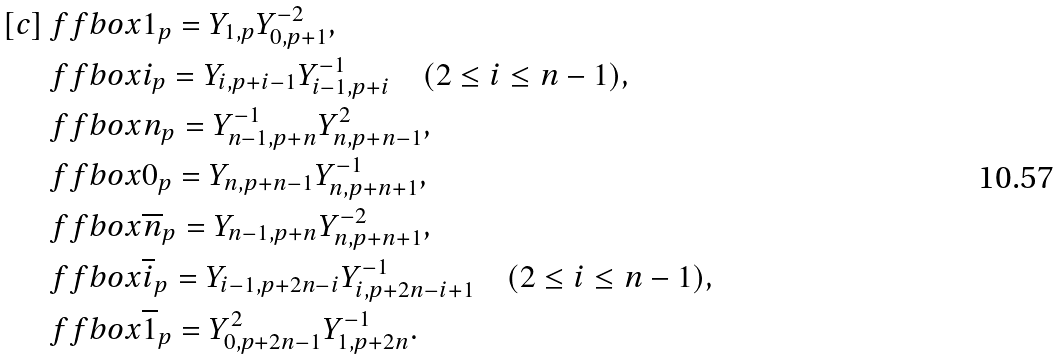Convert formula to latex. <formula><loc_0><loc_0><loc_500><loc_500>[ c ] & \ f f b o x { 1 } _ { p } = Y _ { 1 , p } Y _ { 0 , p + 1 } ^ { - 2 } , \\ & \ f f b o x { i } _ { p } = Y _ { i , p + i - 1 } Y _ { i - 1 , p + i } ^ { - 1 } \quad ( 2 \leq i \leq n - 1 ) , \\ & \ f f b o x { n } _ { p } = Y _ { n - 1 , p + n } ^ { - 1 } Y _ { n , p + n - 1 } ^ { 2 } , \\ & \ f f b o x { 0 } _ { p } = Y _ { n , p + n - 1 } Y _ { n , p + n + 1 } ^ { - 1 } , \\ & \ f f b o x { \overline { n } } _ { p } = Y _ { n - 1 , p + n } Y _ { n , p + n + 1 } ^ { - 2 } , \\ & \ f f b o x { \overline { i } } _ { p } = Y _ { i - 1 , p + 2 n - i } Y _ { i , p + 2 n - i + 1 } ^ { - 1 } \quad ( 2 \leq i \leq n - 1 ) , \\ & \ f f b o x { \overline { 1 } } _ { p } = Y _ { 0 , p + 2 n - 1 } ^ { 2 } Y _ { 1 , p + 2 n } ^ { - 1 } .</formula> 